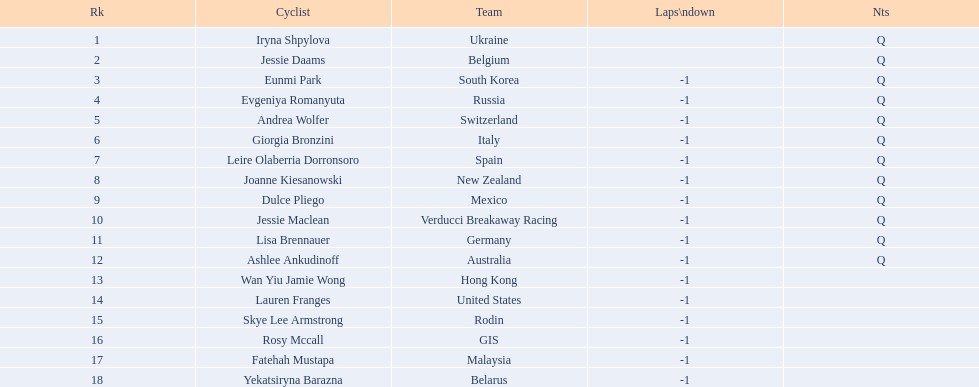Who is the final cyclist mentioned? Yekatsiryna Barazna. 